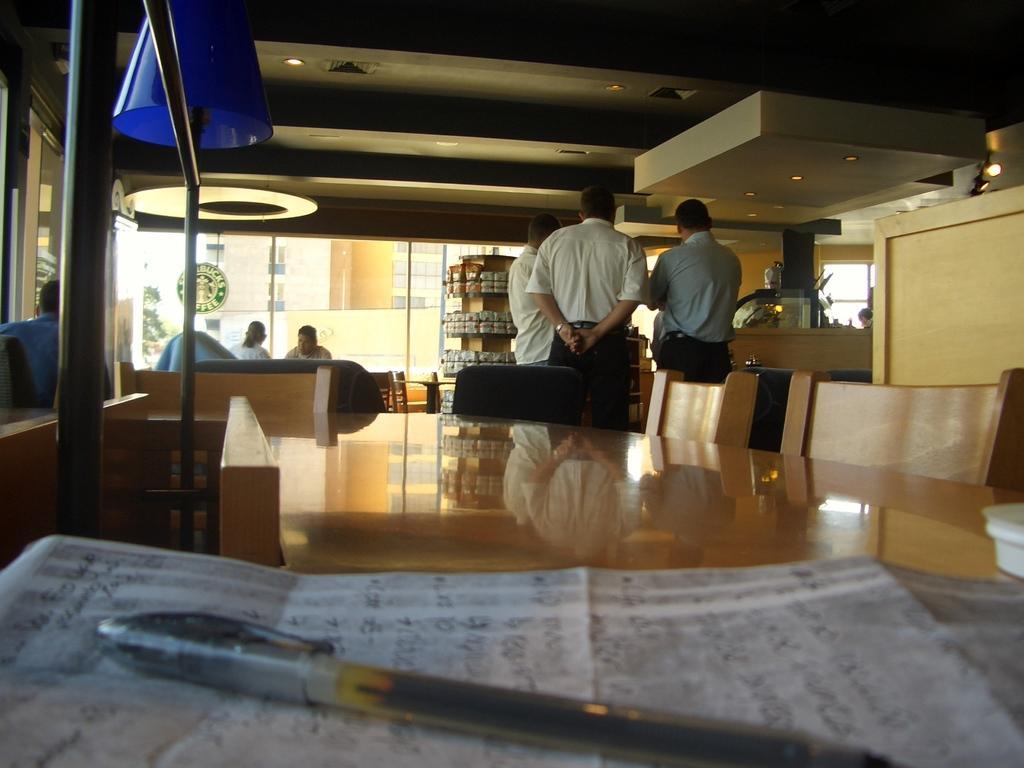How would you summarize this image in a sentence or two? In the picture we can see some persons are sitting and some are standing near the table and chairs, And we can also see pen and paper. In the background we can see a glass doors and some items placed on the racks. 